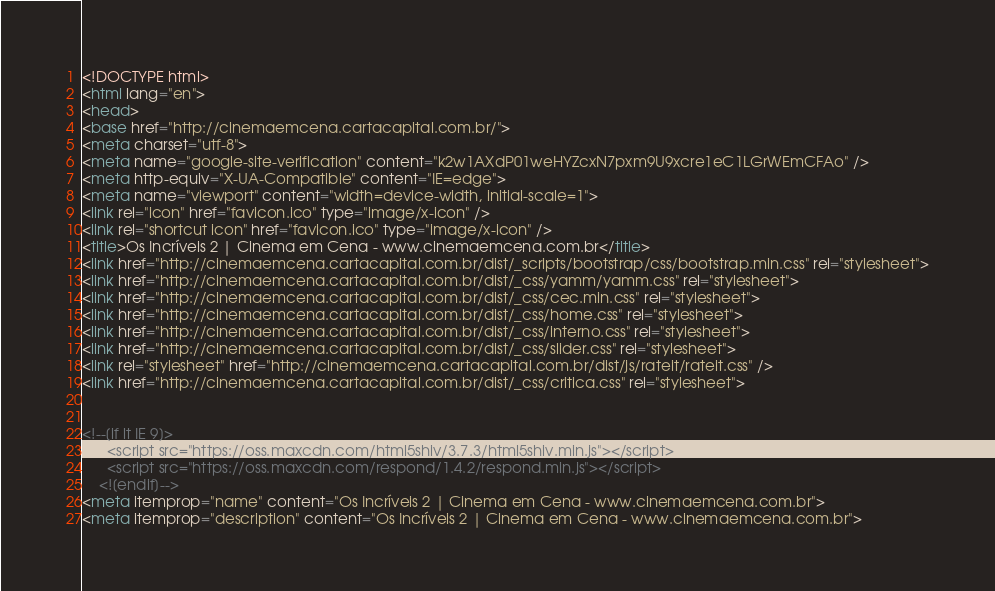<code> <loc_0><loc_0><loc_500><loc_500><_HTML_><!DOCTYPE html>
<html lang="en">
<head>
<base href="http://cinemaemcena.cartacapital.com.br/">
<meta charset="utf-8">
<meta name="google-site-verification" content="k2w1AXdP01weHYZcxN7pxm9U9xcre1eC1LGrWEmCFAo" />
<meta http-equiv="X-UA-Compatible" content="IE=edge">
<meta name="viewport" content="width=device-width, initial-scale=1">
<link rel="icon" href="favicon.ico" type="image/x-icon" />
<link rel="shortcut icon" href="favicon.ico" type="image/x-icon" />
<title>Os Incríveis 2 | Cinema em Cena - www.cinemaemcena.com.br</title>
<link href="http://cinemaemcena.cartacapital.com.br/dist/_scripts/bootstrap/css/bootstrap.min.css" rel="stylesheet">
<link href="http://cinemaemcena.cartacapital.com.br/dist/_css/yamm/yamm.css" rel="stylesheet">
<link href="http://cinemaemcena.cartacapital.com.br/dist/_css/cec.min.css" rel="stylesheet">
<link href="http://cinemaemcena.cartacapital.com.br/dist/_css/home.css" rel="stylesheet">
<link href="http://cinemaemcena.cartacapital.com.br/dist/_css/interno.css" rel="stylesheet">
<link href="http://cinemaemcena.cartacapital.com.br/dist/_css/slider.css" rel="stylesheet">
<link rel="stylesheet" href="http://cinemaemcena.cartacapital.com.br/dist/js/rateit/rateit.css" />
<link href="http://cinemaemcena.cartacapital.com.br/dist/_css/critica.css" rel="stylesheet">


<!--[if lt IE 9]>
      <script src="https://oss.maxcdn.com/html5shiv/3.7.3/html5shiv.min.js"></script>
      <script src="https://oss.maxcdn.com/respond/1.4.2/respond.min.js"></script>
    <![endif]-->
<meta itemprop="name" content="Os Incríveis 2 | Cinema em Cena - www.cinemaemcena.com.br">
<meta itemprop="description" content="Os Incríveis 2 | Cinema em Cena - www.cinemaemcena.com.br"></code> 